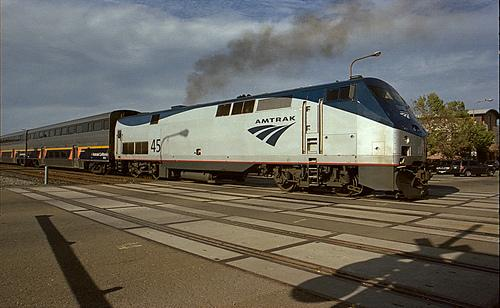What type of environment does the image depict, and what is the weather like? The image depicts a train station environment on a clear blue and sunny day. Describe the entry access to the train along with its additional features for convenience. There is an entry door with hand rails and a step ladder for passengers to access the train easily. What type of vehicle is prominent in this image and what is its color scheme? An Amtrak train is prominent in the image, with a color scheme of grey, blue, and yellow. Mention the number displayed on the side of the train and any logos present. The number 45 is displayed on the side of the train, along with the Amtrak logo and name. Name three objects found near the Amtrak train in the image. A tree with a double trunk, light post, and several cars parked in the train parking lot are found near the Amtrak train. Explain the type of train in the image and its primary function based on the details provided. It's an Amtrak passenger train on tracks, primarily used for transporting people between destinations. Identify the position of the train tracks in relation to the sidewalk and any overlaps. The train tracks are flush with the sidewalk, indicating a seamless integration of both. Give a brief description of the train's immediate surroundings and any notable shadows on the ground. The train is on Amtrak tracks, with train signal shadows and light post shadows on the ground. Count the number of visible train cars in the image, including the front car. There are at least four visible train cars, including the blue and white front car. What action is happening that indicates the train is moving or has recently been moving? Black smoke is rising from the train, indicating that it is moving or has recently been moving. 